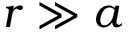Convert formula to latex. <formula><loc_0><loc_0><loc_500><loc_500>r \gg a</formula> 